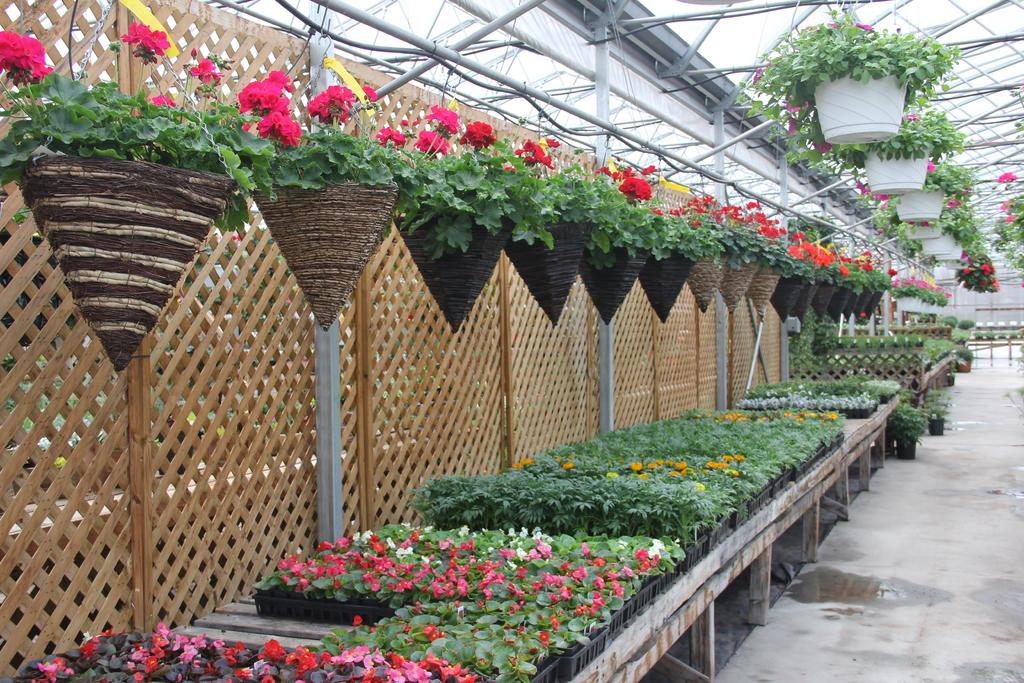What type of objects can be seen in the image? There are flower pots in the image. What colors are the flowers in the image? The flowers in the image are pink, red, and white. What type of structure is present in the image? There is a fencing in the image. What type of building can be seen in the image? There is a shed in the image. What type of button is being pressed in the image? There is no button present in the image. What statement is being made by the flowers in the image? The flowers in the image are not making any statements; they are simply plants with colors. 